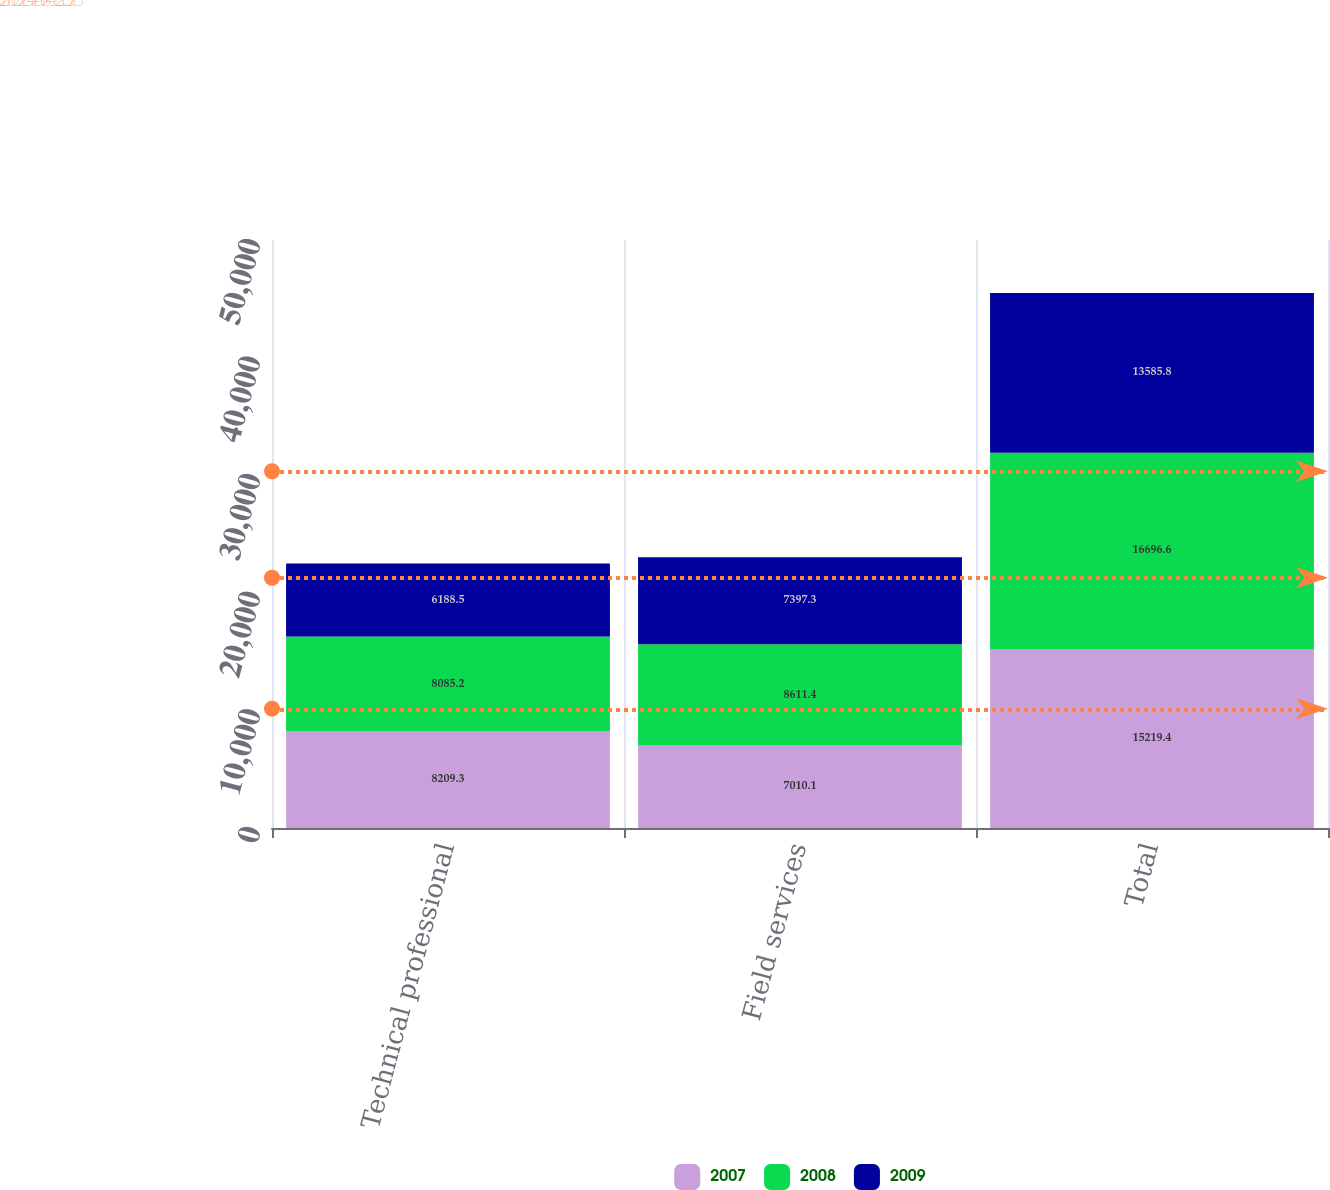Convert chart. <chart><loc_0><loc_0><loc_500><loc_500><stacked_bar_chart><ecel><fcel>Technical professional<fcel>Field services<fcel>Total<nl><fcel>2007<fcel>8209.3<fcel>7010.1<fcel>15219.4<nl><fcel>2008<fcel>8085.2<fcel>8611.4<fcel>16696.6<nl><fcel>2009<fcel>6188.5<fcel>7397.3<fcel>13585.8<nl></chart> 